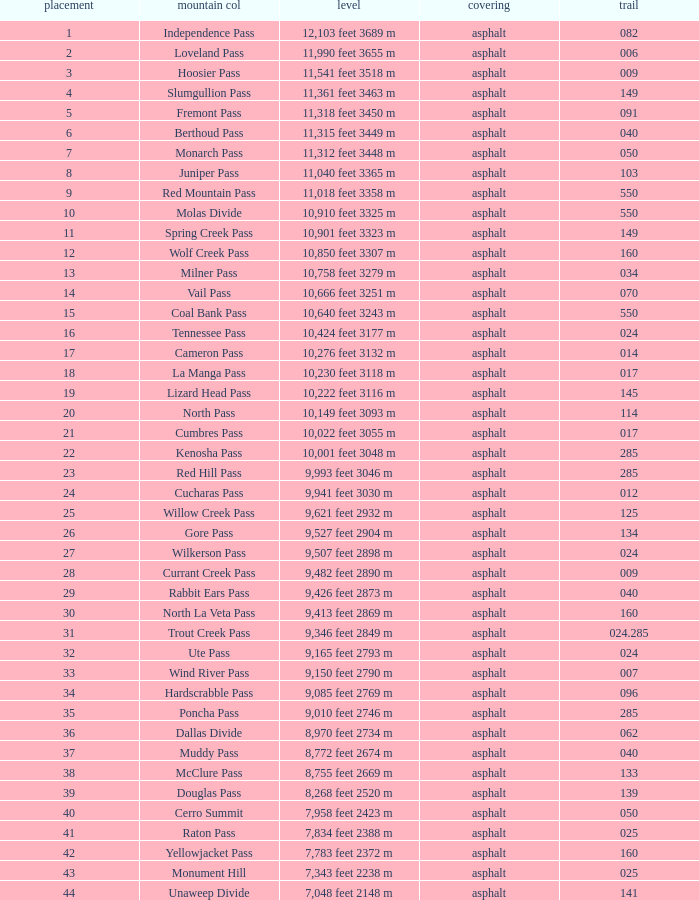What Mountain Pass has an Elevation of 10,001 feet 3048 m? Kenosha Pass. Would you mind parsing the complete table? {'header': ['placement', 'mountain col', 'level', 'covering', 'trail'], 'rows': [['1', 'Independence Pass', '12,103 feet 3689 m', 'asphalt', '082'], ['2', 'Loveland Pass', '11,990 feet 3655 m', 'asphalt', '006'], ['3', 'Hoosier Pass', '11,541 feet 3518 m', 'asphalt', '009'], ['4', 'Slumgullion Pass', '11,361 feet 3463 m', 'asphalt', '149'], ['5', 'Fremont Pass', '11,318 feet 3450 m', 'asphalt', '091'], ['6', 'Berthoud Pass', '11,315 feet 3449 m', 'asphalt', '040'], ['7', 'Monarch Pass', '11,312 feet 3448 m', 'asphalt', '050'], ['8', 'Juniper Pass', '11,040 feet 3365 m', 'asphalt', '103'], ['9', 'Red Mountain Pass', '11,018 feet 3358 m', 'asphalt', '550'], ['10', 'Molas Divide', '10,910 feet 3325 m', 'asphalt', '550'], ['11', 'Spring Creek Pass', '10,901 feet 3323 m', 'asphalt', '149'], ['12', 'Wolf Creek Pass', '10,850 feet 3307 m', 'asphalt', '160'], ['13', 'Milner Pass', '10,758 feet 3279 m', 'asphalt', '034'], ['14', 'Vail Pass', '10,666 feet 3251 m', 'asphalt', '070'], ['15', 'Coal Bank Pass', '10,640 feet 3243 m', 'asphalt', '550'], ['16', 'Tennessee Pass', '10,424 feet 3177 m', 'asphalt', '024'], ['17', 'Cameron Pass', '10,276 feet 3132 m', 'asphalt', '014'], ['18', 'La Manga Pass', '10,230 feet 3118 m', 'asphalt', '017'], ['19', 'Lizard Head Pass', '10,222 feet 3116 m', 'asphalt', '145'], ['20', 'North Pass', '10,149 feet 3093 m', 'asphalt', '114'], ['21', 'Cumbres Pass', '10,022 feet 3055 m', 'asphalt', '017'], ['22', 'Kenosha Pass', '10,001 feet 3048 m', 'asphalt', '285'], ['23', 'Red Hill Pass', '9,993 feet 3046 m', 'asphalt', '285'], ['24', 'Cucharas Pass', '9,941 feet 3030 m', 'asphalt', '012'], ['25', 'Willow Creek Pass', '9,621 feet 2932 m', 'asphalt', '125'], ['26', 'Gore Pass', '9,527 feet 2904 m', 'asphalt', '134'], ['27', 'Wilkerson Pass', '9,507 feet 2898 m', 'asphalt', '024'], ['28', 'Currant Creek Pass', '9,482 feet 2890 m', 'asphalt', '009'], ['29', 'Rabbit Ears Pass', '9,426 feet 2873 m', 'asphalt', '040'], ['30', 'North La Veta Pass', '9,413 feet 2869 m', 'asphalt', '160'], ['31', 'Trout Creek Pass', '9,346 feet 2849 m', 'asphalt', '024.285'], ['32', 'Ute Pass', '9,165 feet 2793 m', 'asphalt', '024'], ['33', 'Wind River Pass', '9,150 feet 2790 m', 'asphalt', '007'], ['34', 'Hardscrabble Pass', '9,085 feet 2769 m', 'asphalt', '096'], ['35', 'Poncha Pass', '9,010 feet 2746 m', 'asphalt', '285'], ['36', 'Dallas Divide', '8,970 feet 2734 m', 'asphalt', '062'], ['37', 'Muddy Pass', '8,772 feet 2674 m', 'asphalt', '040'], ['38', 'McClure Pass', '8,755 feet 2669 m', 'asphalt', '133'], ['39', 'Douglas Pass', '8,268 feet 2520 m', 'asphalt', '139'], ['40', 'Cerro Summit', '7,958 feet 2423 m', 'asphalt', '050'], ['41', 'Raton Pass', '7,834 feet 2388 m', 'asphalt', '025'], ['42', 'Yellowjacket Pass', '7,783 feet 2372 m', 'asphalt', '160'], ['43', 'Monument Hill', '7,343 feet 2238 m', 'asphalt', '025'], ['44', 'Unaweep Divide', '7,048 feet 2148 m', 'asphalt', '141']]} 